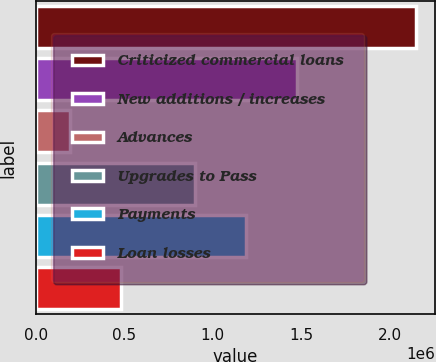Convert chart to OTSL. <chart><loc_0><loc_0><loc_500><loc_500><bar_chart><fcel>Criticized commercial loans<fcel>New additions / increases<fcel>Advances<fcel>Upgrades to Pass<fcel>Payments<fcel>Loan losses<nl><fcel>2.14661e+06<fcel>1.47779e+06<fcel>193679<fcel>901633<fcel>1.18971e+06<fcel>481759<nl></chart> 